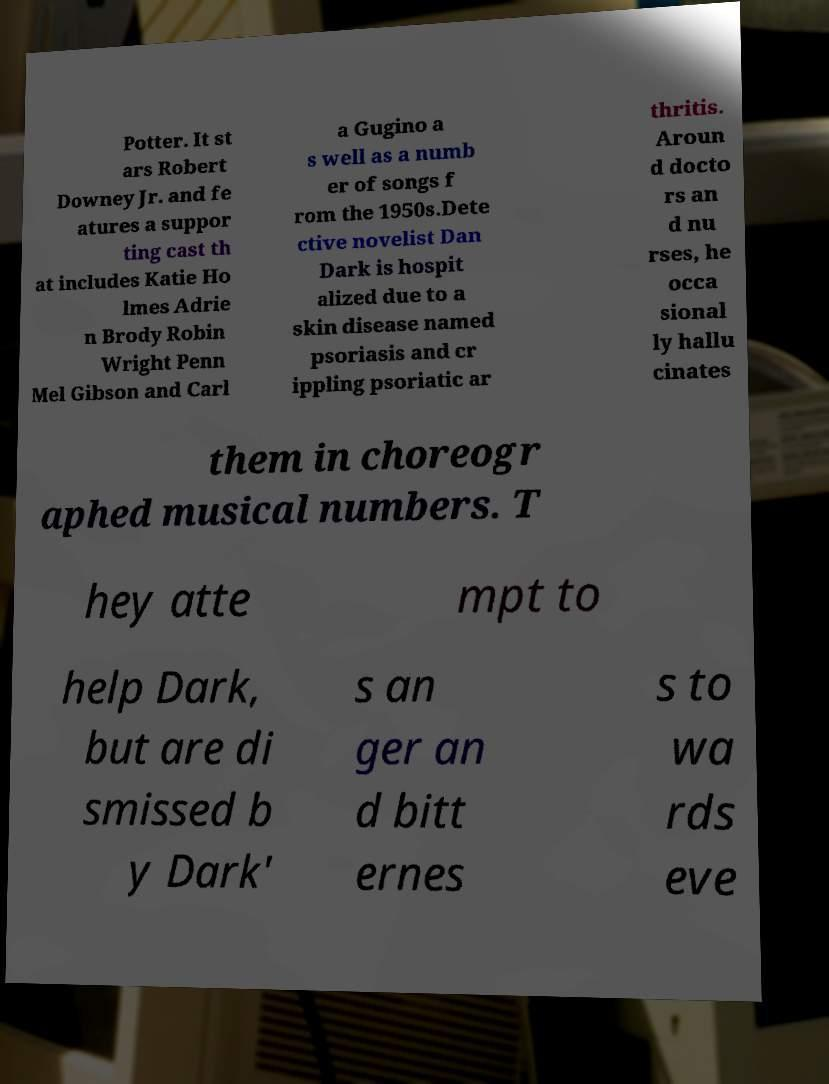What messages or text are displayed in this image? I need them in a readable, typed format. Potter. It st ars Robert Downey Jr. and fe atures a suppor ting cast th at includes Katie Ho lmes Adrie n Brody Robin Wright Penn Mel Gibson and Carl a Gugino a s well as a numb er of songs f rom the 1950s.Dete ctive novelist Dan Dark is hospit alized due to a skin disease named psoriasis and cr ippling psoriatic ar thritis. Aroun d docto rs an d nu rses, he occa sional ly hallu cinates them in choreogr aphed musical numbers. T hey atte mpt to help Dark, but are di smissed b y Dark' s an ger an d bitt ernes s to wa rds eve 